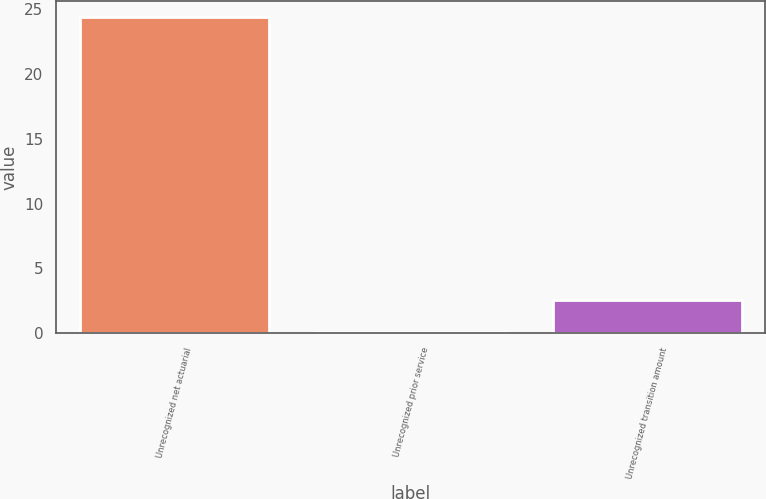<chart> <loc_0><loc_0><loc_500><loc_500><bar_chart><fcel>Unrecognized net actuarial<fcel>Unrecognized prior service<fcel>Unrecognized transition amount<nl><fcel>24.4<fcel>0.1<fcel>2.53<nl></chart> 